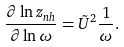Convert formula to latex. <formula><loc_0><loc_0><loc_500><loc_500>\frac { \partial \ln z _ { n h } } { \partial \ln \omega } = \tilde { U } ^ { 2 } \frac { 1 } { \omega } .</formula> 